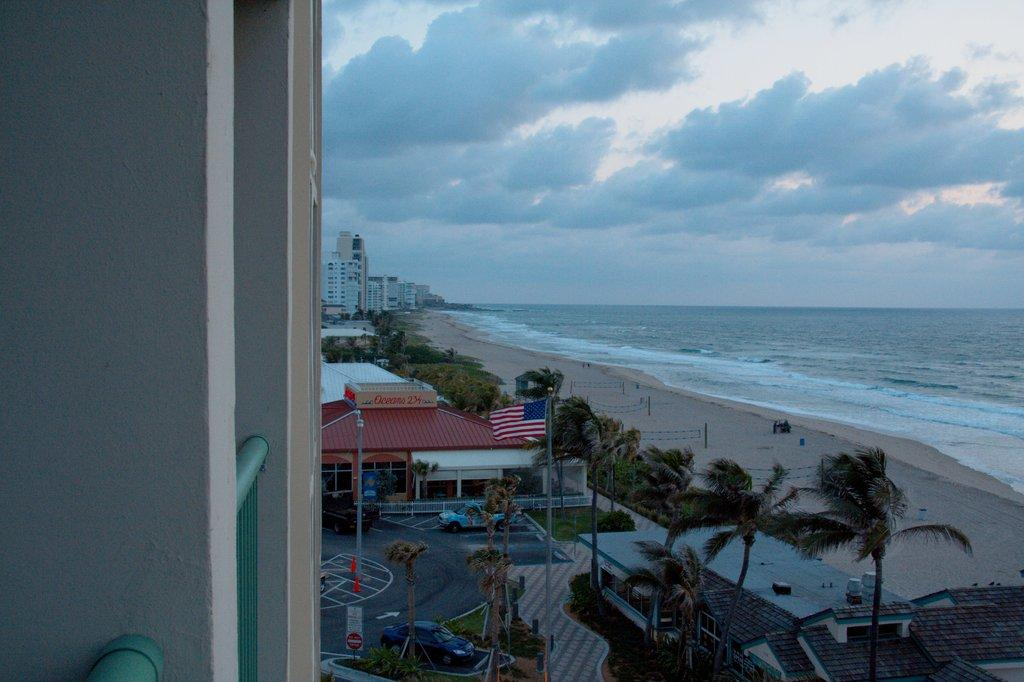What type of natural vegetation is present in the image? There is a group of trees in the image. What type of man-made structures can be seen in the image? There are buildings in the image. What type of transportation is visible in the image? There are vehicles in the image. What type of landscape can be seen on the right side of the image? There is a beach visible on the right side of the image. What type of architectural feature is visible on the left side of the image? There is a building wall visible on the left side of the image. What type of fang can be seen in the image? There is no fang present in the image. What type of view can be seen from the top of the building in the image? The image does not show a view from the top of a building, so it cannot be determined. 